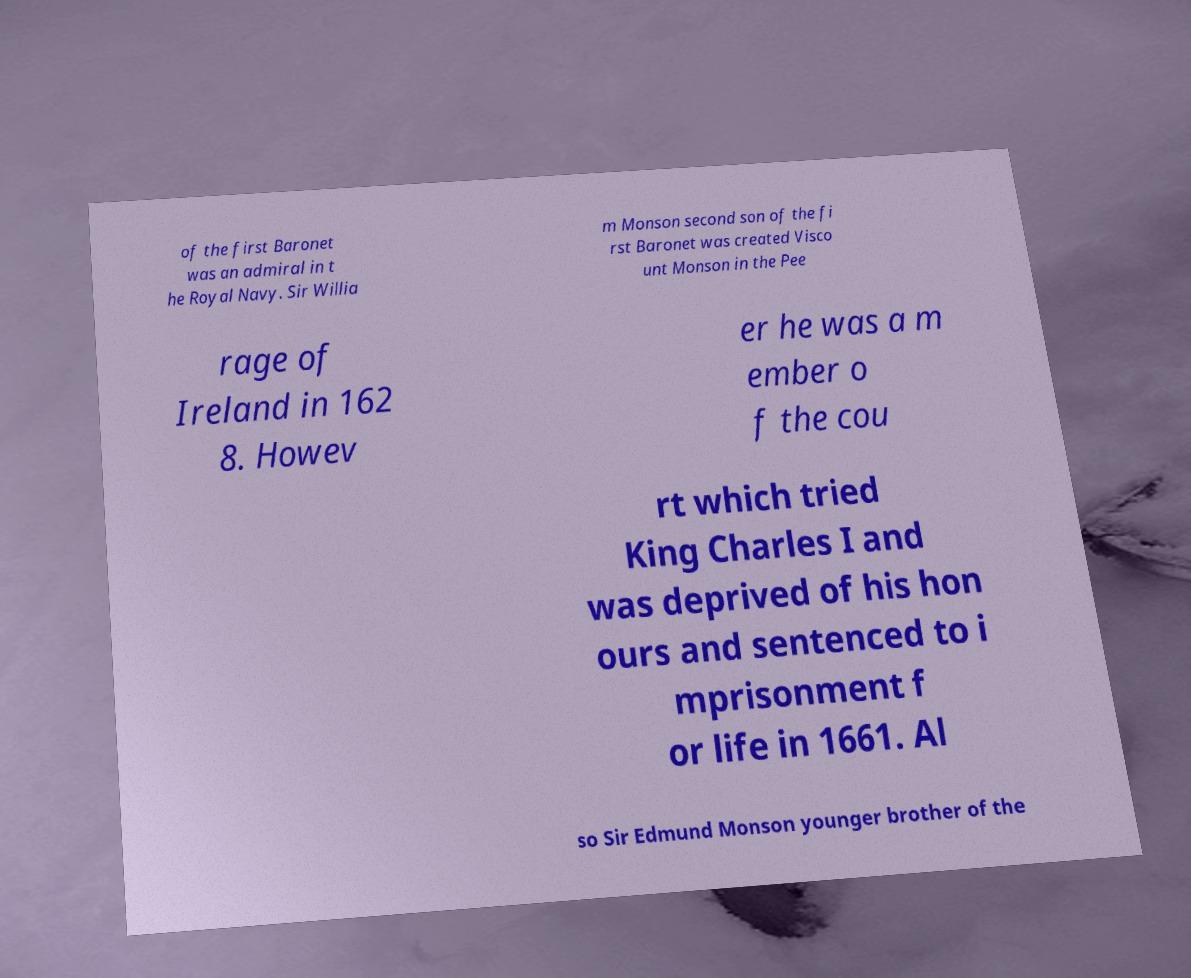For documentation purposes, I need the text within this image transcribed. Could you provide that? of the first Baronet was an admiral in t he Royal Navy. Sir Willia m Monson second son of the fi rst Baronet was created Visco unt Monson in the Pee rage of Ireland in 162 8. Howev er he was a m ember o f the cou rt which tried King Charles I and was deprived of his hon ours and sentenced to i mprisonment f or life in 1661. Al so Sir Edmund Monson younger brother of the 